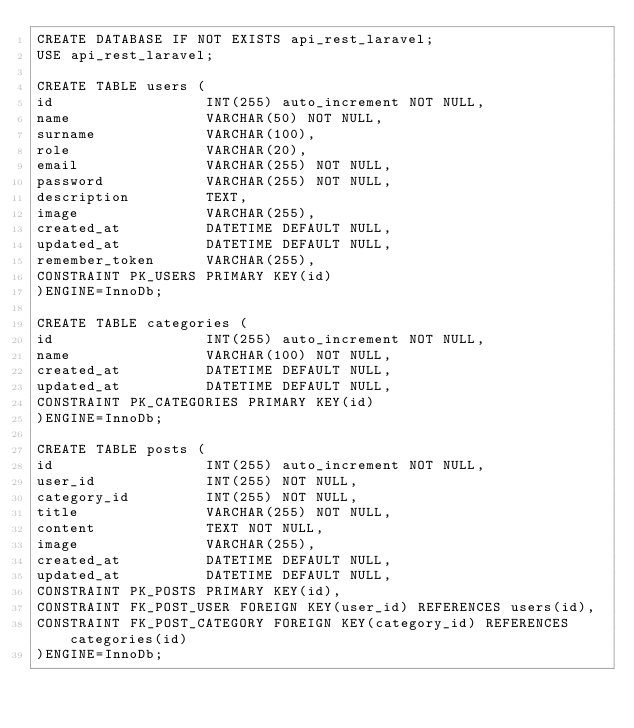Convert code to text. <code><loc_0><loc_0><loc_500><loc_500><_SQL_>CREATE DATABASE IF NOT EXISTS api_rest_laravel;
USE api_rest_laravel;

CREATE TABLE users (
id                  INT(255) auto_increment NOT NULL, 
name                VARCHAR(50) NOT NULL,
surname             VARCHAR(100),
role                VARCHAR(20),
email               VARCHAR(255) NOT NULL,
password            VARCHAR(255) NOT NULL,
description         TEXT,
image               VARCHAR(255),
created_at          DATETIME DEFAULT NULL,
updated_at          DATETIME DEFAULT NULL,
remember_token      VARCHAR(255),
CONSTRAINT PK_USERS PRIMARY KEY(id)
)ENGINE=InnoDb;

CREATE TABLE categories (
id                  INT(255) auto_increment NOT NULL, 
name                VARCHAR(100) NOT NULL,
created_at          DATETIME DEFAULT NULL,
updated_at          DATETIME DEFAULT NULL,
CONSTRAINT PK_CATEGORIES PRIMARY KEY(id)
)ENGINE=InnoDb;

CREATE TABLE posts (
id                  INT(255) auto_increment NOT NULL, 
user_id             INT(255) NOT NULL,
category_id         INT(255) NOT NULL,
title               VARCHAR(255) NOT NULL,
content             TEXT NOT NULL,
image               VARCHAR(255),
created_at          DATETIME DEFAULT NULL,
updated_at          DATETIME DEFAULT NULL,
CONSTRAINT PK_POSTS PRIMARY KEY(id),
CONSTRAINT FK_POST_USER FOREIGN KEY(user_id) REFERENCES users(id),
CONSTRAINT FK_POST_CATEGORY FOREIGN KEY(category_id) REFERENCES categories(id)
)ENGINE=InnoDb;</code> 